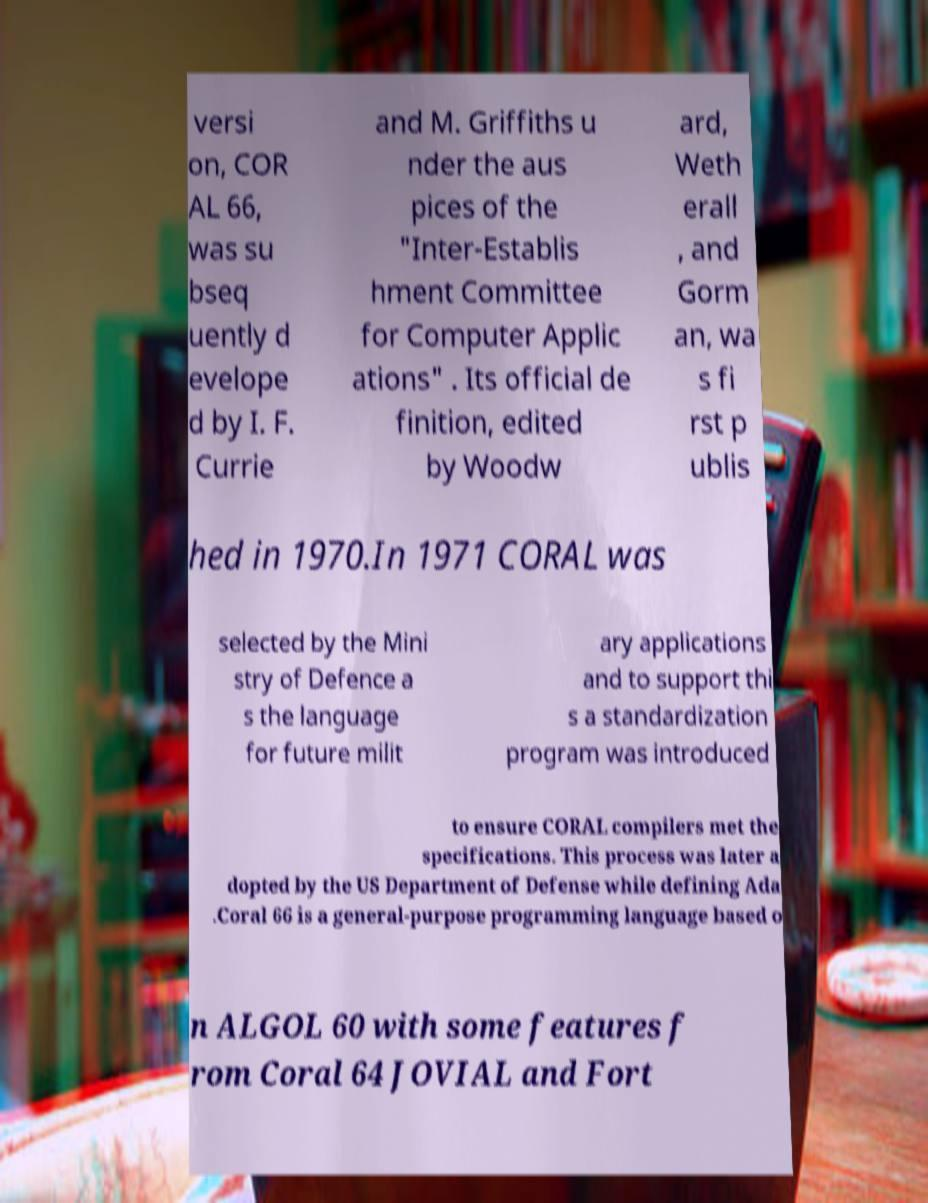Please read and relay the text visible in this image. What does it say? versi on, COR AL 66, was su bseq uently d evelope d by I. F. Currie and M. Griffiths u nder the aus pices of the "Inter-Establis hment Committee for Computer Applic ations" . Its official de finition, edited by Woodw ard, Weth erall , and Gorm an, wa s fi rst p ublis hed in 1970.In 1971 CORAL was selected by the Mini stry of Defence a s the language for future milit ary applications and to support thi s a standardization program was introduced to ensure CORAL compilers met the specifications. This process was later a dopted by the US Department of Defense while defining Ada .Coral 66 is a general-purpose programming language based o n ALGOL 60 with some features f rom Coral 64 JOVIAL and Fort 